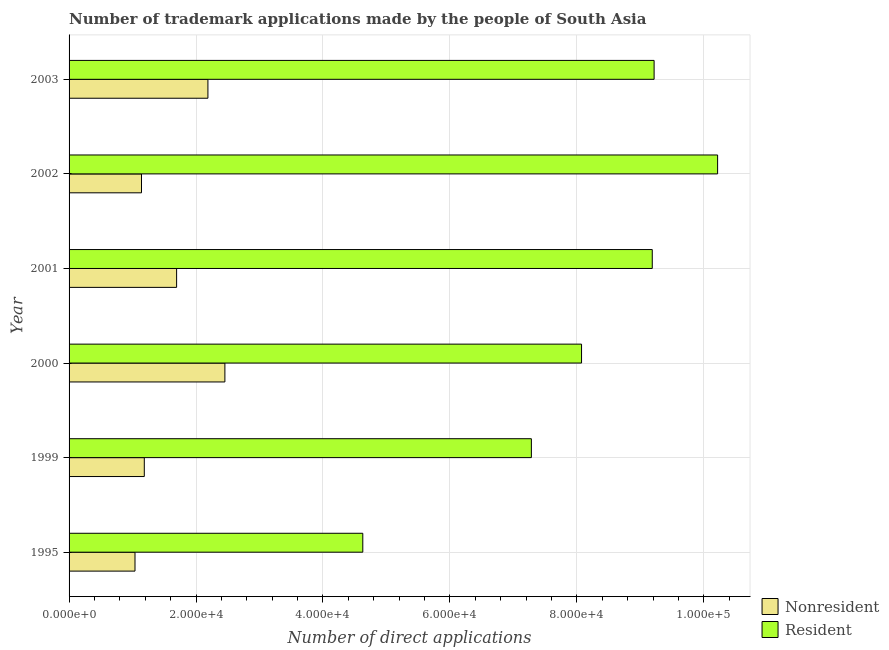Are the number of bars per tick equal to the number of legend labels?
Your answer should be very brief. Yes. Are the number of bars on each tick of the Y-axis equal?
Your response must be concise. Yes. What is the label of the 1st group of bars from the top?
Make the answer very short. 2003. What is the number of trademark applications made by non residents in 2001?
Your response must be concise. 1.69e+04. Across all years, what is the maximum number of trademark applications made by non residents?
Provide a succinct answer. 2.45e+04. Across all years, what is the minimum number of trademark applications made by non residents?
Your answer should be compact. 1.04e+04. What is the total number of trademark applications made by non residents in the graph?
Offer a very short reply. 9.70e+04. What is the difference between the number of trademark applications made by non residents in 2001 and that in 2003?
Ensure brevity in your answer.  -4933. What is the difference between the number of trademark applications made by non residents in 2002 and the number of trademark applications made by residents in 1999?
Give a very brief answer. -6.14e+04. What is the average number of trademark applications made by residents per year?
Ensure brevity in your answer.  8.10e+04. In the year 1999, what is the difference between the number of trademark applications made by residents and number of trademark applications made by non residents?
Your response must be concise. 6.10e+04. What is the ratio of the number of trademark applications made by non residents in 2001 to that in 2002?
Give a very brief answer. 1.49. Is the difference between the number of trademark applications made by non residents in 2002 and 2003 greater than the difference between the number of trademark applications made by residents in 2002 and 2003?
Your answer should be compact. No. What is the difference between the highest and the second highest number of trademark applications made by residents?
Offer a terse response. 1.00e+04. What is the difference between the highest and the lowest number of trademark applications made by residents?
Offer a terse response. 5.59e+04. Is the sum of the number of trademark applications made by non residents in 1999 and 2001 greater than the maximum number of trademark applications made by residents across all years?
Offer a terse response. No. What does the 1st bar from the top in 2000 represents?
Offer a terse response. Resident. What does the 1st bar from the bottom in 2003 represents?
Ensure brevity in your answer.  Nonresident. How many bars are there?
Your response must be concise. 12. Are all the bars in the graph horizontal?
Your answer should be compact. Yes. How many years are there in the graph?
Your response must be concise. 6. Are the values on the major ticks of X-axis written in scientific E-notation?
Your response must be concise. Yes. Does the graph contain any zero values?
Give a very brief answer. No. Does the graph contain grids?
Provide a succinct answer. Yes. What is the title of the graph?
Provide a short and direct response. Number of trademark applications made by the people of South Asia. What is the label or title of the X-axis?
Your answer should be very brief. Number of direct applications. What is the label or title of the Y-axis?
Provide a succinct answer. Year. What is the Number of direct applications in Nonresident in 1995?
Give a very brief answer. 1.04e+04. What is the Number of direct applications in Resident in 1995?
Your answer should be very brief. 4.63e+04. What is the Number of direct applications in Nonresident in 1999?
Provide a short and direct response. 1.19e+04. What is the Number of direct applications in Resident in 1999?
Keep it short and to the point. 7.28e+04. What is the Number of direct applications of Nonresident in 2000?
Offer a very short reply. 2.45e+04. What is the Number of direct applications of Resident in 2000?
Ensure brevity in your answer.  8.07e+04. What is the Number of direct applications of Nonresident in 2001?
Ensure brevity in your answer.  1.69e+04. What is the Number of direct applications of Resident in 2001?
Provide a short and direct response. 9.19e+04. What is the Number of direct applications of Nonresident in 2002?
Your answer should be compact. 1.14e+04. What is the Number of direct applications of Resident in 2002?
Keep it short and to the point. 1.02e+05. What is the Number of direct applications in Nonresident in 2003?
Your response must be concise. 2.19e+04. What is the Number of direct applications in Resident in 2003?
Provide a short and direct response. 9.22e+04. Across all years, what is the maximum Number of direct applications of Nonresident?
Ensure brevity in your answer.  2.45e+04. Across all years, what is the maximum Number of direct applications of Resident?
Provide a short and direct response. 1.02e+05. Across all years, what is the minimum Number of direct applications in Nonresident?
Provide a succinct answer. 1.04e+04. Across all years, what is the minimum Number of direct applications of Resident?
Provide a succinct answer. 4.63e+04. What is the total Number of direct applications in Nonresident in the graph?
Give a very brief answer. 9.70e+04. What is the total Number of direct applications of Resident in the graph?
Provide a succinct answer. 4.86e+05. What is the difference between the Number of direct applications in Nonresident in 1995 and that in 1999?
Provide a succinct answer. -1465. What is the difference between the Number of direct applications of Resident in 1995 and that in 1999?
Your answer should be very brief. -2.66e+04. What is the difference between the Number of direct applications in Nonresident in 1995 and that in 2000?
Offer a terse response. -1.42e+04. What is the difference between the Number of direct applications in Resident in 1995 and that in 2000?
Keep it short and to the point. -3.45e+04. What is the difference between the Number of direct applications in Nonresident in 1995 and that in 2001?
Your response must be concise. -6556. What is the difference between the Number of direct applications of Resident in 1995 and that in 2001?
Your answer should be very brief. -4.56e+04. What is the difference between the Number of direct applications of Nonresident in 1995 and that in 2002?
Make the answer very short. -1023. What is the difference between the Number of direct applications of Resident in 1995 and that in 2002?
Provide a short and direct response. -5.59e+04. What is the difference between the Number of direct applications of Nonresident in 1995 and that in 2003?
Give a very brief answer. -1.15e+04. What is the difference between the Number of direct applications of Resident in 1995 and that in 2003?
Make the answer very short. -4.59e+04. What is the difference between the Number of direct applications in Nonresident in 1999 and that in 2000?
Provide a short and direct response. -1.27e+04. What is the difference between the Number of direct applications of Resident in 1999 and that in 2000?
Your answer should be compact. -7903. What is the difference between the Number of direct applications in Nonresident in 1999 and that in 2001?
Ensure brevity in your answer.  -5091. What is the difference between the Number of direct applications of Resident in 1999 and that in 2001?
Offer a very short reply. -1.90e+04. What is the difference between the Number of direct applications of Nonresident in 1999 and that in 2002?
Offer a terse response. 442. What is the difference between the Number of direct applications in Resident in 1999 and that in 2002?
Your answer should be very brief. -2.93e+04. What is the difference between the Number of direct applications of Nonresident in 1999 and that in 2003?
Your answer should be compact. -1.00e+04. What is the difference between the Number of direct applications in Resident in 1999 and that in 2003?
Your response must be concise. -1.93e+04. What is the difference between the Number of direct applications in Nonresident in 2000 and that in 2001?
Offer a terse response. 7606. What is the difference between the Number of direct applications of Resident in 2000 and that in 2001?
Provide a short and direct response. -1.11e+04. What is the difference between the Number of direct applications of Nonresident in 2000 and that in 2002?
Offer a very short reply. 1.31e+04. What is the difference between the Number of direct applications in Resident in 2000 and that in 2002?
Provide a short and direct response. -2.14e+04. What is the difference between the Number of direct applications of Nonresident in 2000 and that in 2003?
Give a very brief answer. 2673. What is the difference between the Number of direct applications in Resident in 2000 and that in 2003?
Your response must be concise. -1.14e+04. What is the difference between the Number of direct applications of Nonresident in 2001 and that in 2002?
Your answer should be compact. 5533. What is the difference between the Number of direct applications of Resident in 2001 and that in 2002?
Provide a short and direct response. -1.03e+04. What is the difference between the Number of direct applications in Nonresident in 2001 and that in 2003?
Offer a very short reply. -4933. What is the difference between the Number of direct applications of Resident in 2001 and that in 2003?
Your answer should be very brief. -291. What is the difference between the Number of direct applications of Nonresident in 2002 and that in 2003?
Offer a very short reply. -1.05e+04. What is the difference between the Number of direct applications of Resident in 2002 and that in 2003?
Your answer should be very brief. 1.00e+04. What is the difference between the Number of direct applications of Nonresident in 1995 and the Number of direct applications of Resident in 1999?
Ensure brevity in your answer.  -6.24e+04. What is the difference between the Number of direct applications of Nonresident in 1995 and the Number of direct applications of Resident in 2000?
Provide a succinct answer. -7.03e+04. What is the difference between the Number of direct applications of Nonresident in 1995 and the Number of direct applications of Resident in 2001?
Give a very brief answer. -8.15e+04. What is the difference between the Number of direct applications of Nonresident in 1995 and the Number of direct applications of Resident in 2002?
Ensure brevity in your answer.  -9.18e+04. What is the difference between the Number of direct applications in Nonresident in 1995 and the Number of direct applications in Resident in 2003?
Make the answer very short. -8.18e+04. What is the difference between the Number of direct applications of Nonresident in 1999 and the Number of direct applications of Resident in 2000?
Make the answer very short. -6.89e+04. What is the difference between the Number of direct applications in Nonresident in 1999 and the Number of direct applications in Resident in 2001?
Keep it short and to the point. -8.00e+04. What is the difference between the Number of direct applications in Nonresident in 1999 and the Number of direct applications in Resident in 2002?
Provide a short and direct response. -9.03e+04. What is the difference between the Number of direct applications in Nonresident in 1999 and the Number of direct applications in Resident in 2003?
Make the answer very short. -8.03e+04. What is the difference between the Number of direct applications of Nonresident in 2000 and the Number of direct applications of Resident in 2001?
Give a very brief answer. -6.73e+04. What is the difference between the Number of direct applications of Nonresident in 2000 and the Number of direct applications of Resident in 2002?
Ensure brevity in your answer.  -7.76e+04. What is the difference between the Number of direct applications in Nonresident in 2000 and the Number of direct applications in Resident in 2003?
Make the answer very short. -6.76e+04. What is the difference between the Number of direct applications in Nonresident in 2001 and the Number of direct applications in Resident in 2002?
Provide a succinct answer. -8.52e+04. What is the difference between the Number of direct applications of Nonresident in 2001 and the Number of direct applications of Resident in 2003?
Provide a short and direct response. -7.52e+04. What is the difference between the Number of direct applications of Nonresident in 2002 and the Number of direct applications of Resident in 2003?
Provide a succinct answer. -8.08e+04. What is the average Number of direct applications of Nonresident per year?
Your answer should be compact. 1.62e+04. What is the average Number of direct applications of Resident per year?
Give a very brief answer. 8.10e+04. In the year 1995, what is the difference between the Number of direct applications in Nonresident and Number of direct applications in Resident?
Offer a very short reply. -3.59e+04. In the year 1999, what is the difference between the Number of direct applications in Nonresident and Number of direct applications in Resident?
Give a very brief answer. -6.10e+04. In the year 2000, what is the difference between the Number of direct applications of Nonresident and Number of direct applications of Resident?
Your response must be concise. -5.62e+04. In the year 2001, what is the difference between the Number of direct applications in Nonresident and Number of direct applications in Resident?
Ensure brevity in your answer.  -7.49e+04. In the year 2002, what is the difference between the Number of direct applications in Nonresident and Number of direct applications in Resident?
Your response must be concise. -9.08e+04. In the year 2003, what is the difference between the Number of direct applications in Nonresident and Number of direct applications in Resident?
Make the answer very short. -7.03e+04. What is the ratio of the Number of direct applications in Nonresident in 1995 to that in 1999?
Your answer should be very brief. 0.88. What is the ratio of the Number of direct applications of Resident in 1995 to that in 1999?
Your answer should be very brief. 0.64. What is the ratio of the Number of direct applications in Nonresident in 1995 to that in 2000?
Provide a short and direct response. 0.42. What is the ratio of the Number of direct applications in Resident in 1995 to that in 2000?
Ensure brevity in your answer.  0.57. What is the ratio of the Number of direct applications of Nonresident in 1995 to that in 2001?
Offer a terse response. 0.61. What is the ratio of the Number of direct applications of Resident in 1995 to that in 2001?
Offer a terse response. 0.5. What is the ratio of the Number of direct applications in Nonresident in 1995 to that in 2002?
Provide a short and direct response. 0.91. What is the ratio of the Number of direct applications in Resident in 1995 to that in 2002?
Keep it short and to the point. 0.45. What is the ratio of the Number of direct applications of Nonresident in 1995 to that in 2003?
Offer a terse response. 0.47. What is the ratio of the Number of direct applications of Resident in 1995 to that in 2003?
Your response must be concise. 0.5. What is the ratio of the Number of direct applications of Nonresident in 1999 to that in 2000?
Your response must be concise. 0.48. What is the ratio of the Number of direct applications in Resident in 1999 to that in 2000?
Provide a short and direct response. 0.9. What is the ratio of the Number of direct applications of Nonresident in 1999 to that in 2001?
Your answer should be compact. 0.7. What is the ratio of the Number of direct applications of Resident in 1999 to that in 2001?
Offer a terse response. 0.79. What is the ratio of the Number of direct applications of Nonresident in 1999 to that in 2002?
Offer a terse response. 1.04. What is the ratio of the Number of direct applications of Resident in 1999 to that in 2002?
Provide a succinct answer. 0.71. What is the ratio of the Number of direct applications in Nonresident in 1999 to that in 2003?
Provide a succinct answer. 0.54. What is the ratio of the Number of direct applications in Resident in 1999 to that in 2003?
Provide a short and direct response. 0.79. What is the ratio of the Number of direct applications of Nonresident in 2000 to that in 2001?
Offer a terse response. 1.45. What is the ratio of the Number of direct applications of Resident in 2000 to that in 2001?
Give a very brief answer. 0.88. What is the ratio of the Number of direct applications of Nonresident in 2000 to that in 2002?
Your answer should be very brief. 2.15. What is the ratio of the Number of direct applications of Resident in 2000 to that in 2002?
Give a very brief answer. 0.79. What is the ratio of the Number of direct applications of Nonresident in 2000 to that in 2003?
Ensure brevity in your answer.  1.12. What is the ratio of the Number of direct applications of Resident in 2000 to that in 2003?
Make the answer very short. 0.88. What is the ratio of the Number of direct applications in Nonresident in 2001 to that in 2002?
Your answer should be very brief. 1.49. What is the ratio of the Number of direct applications in Resident in 2001 to that in 2002?
Offer a terse response. 0.9. What is the ratio of the Number of direct applications in Nonresident in 2001 to that in 2003?
Your response must be concise. 0.77. What is the ratio of the Number of direct applications of Nonresident in 2002 to that in 2003?
Offer a very short reply. 0.52. What is the ratio of the Number of direct applications in Resident in 2002 to that in 2003?
Your response must be concise. 1.11. What is the difference between the highest and the second highest Number of direct applications in Nonresident?
Offer a terse response. 2673. What is the difference between the highest and the second highest Number of direct applications in Resident?
Keep it short and to the point. 1.00e+04. What is the difference between the highest and the lowest Number of direct applications in Nonresident?
Provide a short and direct response. 1.42e+04. What is the difference between the highest and the lowest Number of direct applications in Resident?
Offer a very short reply. 5.59e+04. 